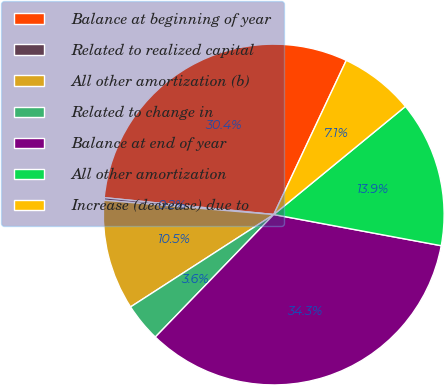Convert chart. <chart><loc_0><loc_0><loc_500><loc_500><pie_chart><fcel>Balance at beginning of year<fcel>Related to realized capital<fcel>All other amortization (b)<fcel>Related to change in<fcel>Balance at end of year<fcel>All other amortization<fcel>Increase (decrease) due to<nl><fcel>30.42%<fcel>0.24%<fcel>10.46%<fcel>3.65%<fcel>34.3%<fcel>13.87%<fcel>7.06%<nl></chart> 